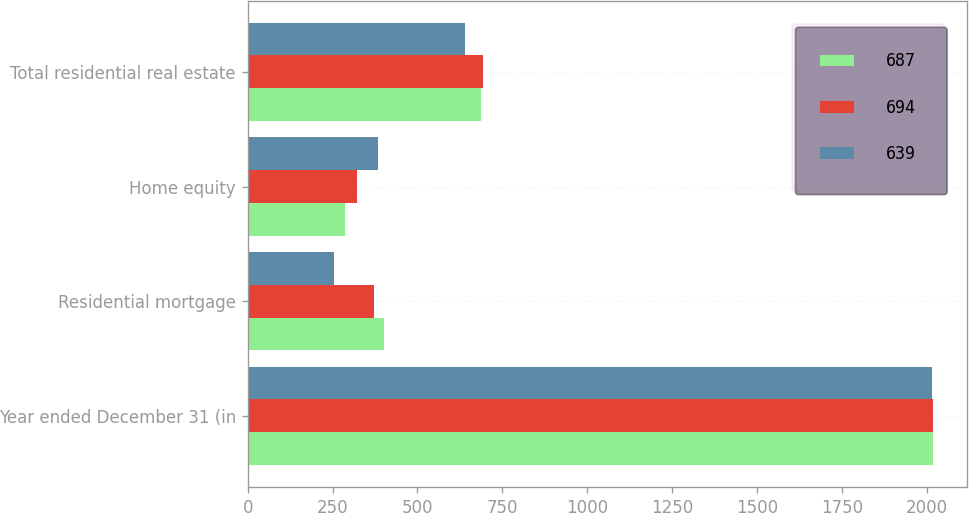Convert chart. <chart><loc_0><loc_0><loc_500><loc_500><stacked_bar_chart><ecel><fcel>Year ended December 31 (in<fcel>Residential mortgage<fcel>Home equity<fcel>Total residential real estate<nl><fcel>687<fcel>2018<fcel>401<fcel>286<fcel>687<nl><fcel>694<fcel>2017<fcel>373<fcel>321<fcel>694<nl><fcel>639<fcel>2016<fcel>254<fcel>385<fcel>639<nl></chart> 